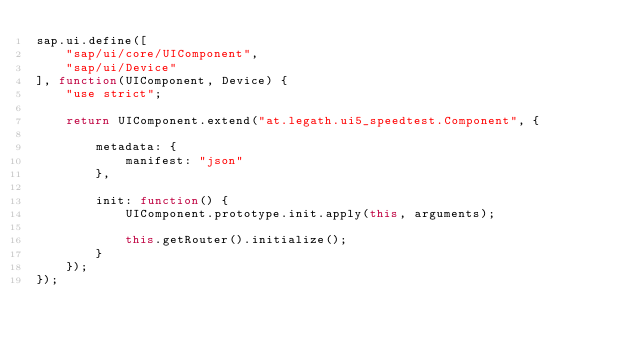Convert code to text. <code><loc_0><loc_0><loc_500><loc_500><_JavaScript_>sap.ui.define([
	"sap/ui/core/UIComponent",
	"sap/ui/Device"
], function(UIComponent, Device) {
	"use strict";

	return UIComponent.extend("at.legath.ui5_speedtest.Component", {

		metadata: {
			manifest: "json"
		},

		init: function() {
			UIComponent.prototype.init.apply(this, arguments);
			
			this.getRouter().initialize();
		}
	});
});</code> 